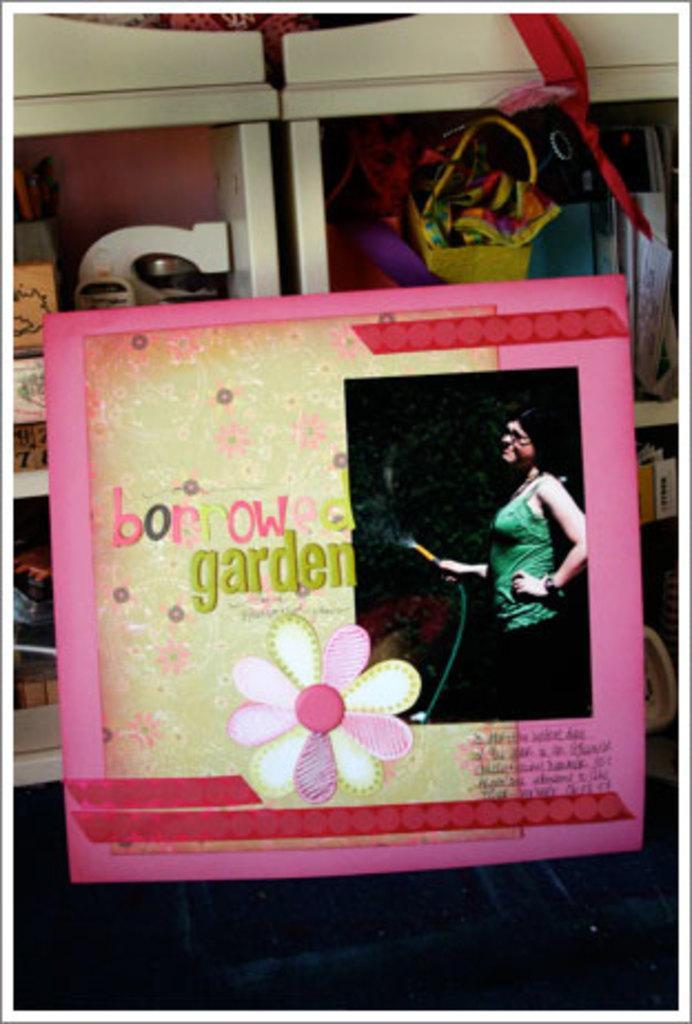Describe this image in one or two sentences. In the image I can see a frame to which there is the design of a flower and behind there are some other things in the shelves. 